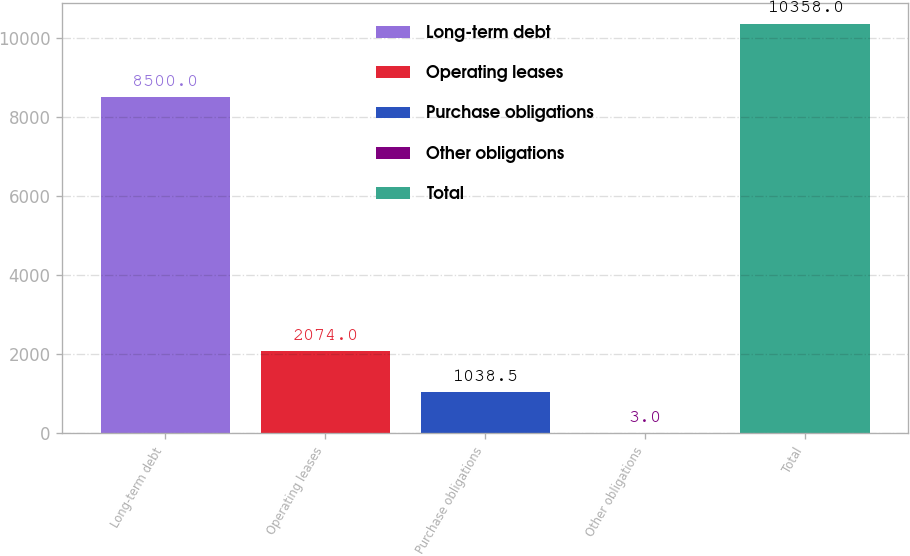Convert chart to OTSL. <chart><loc_0><loc_0><loc_500><loc_500><bar_chart><fcel>Long-term debt<fcel>Operating leases<fcel>Purchase obligations<fcel>Other obligations<fcel>Total<nl><fcel>8500<fcel>2074<fcel>1038.5<fcel>3<fcel>10358<nl></chart> 